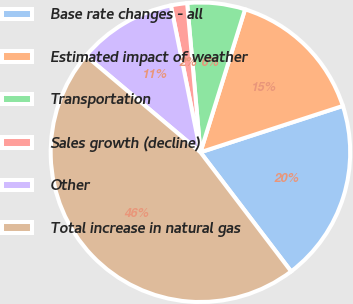Convert chart to OTSL. <chart><loc_0><loc_0><loc_500><loc_500><pie_chart><fcel>Base rate changes - all<fcel>Estimated impact of weather<fcel>Transportation<fcel>Sales growth (decline)<fcel>Other<fcel>Total increase in natural gas<nl><fcel>19.65%<fcel>15.18%<fcel>6.23%<fcel>1.75%<fcel>10.7%<fcel>46.49%<nl></chart> 